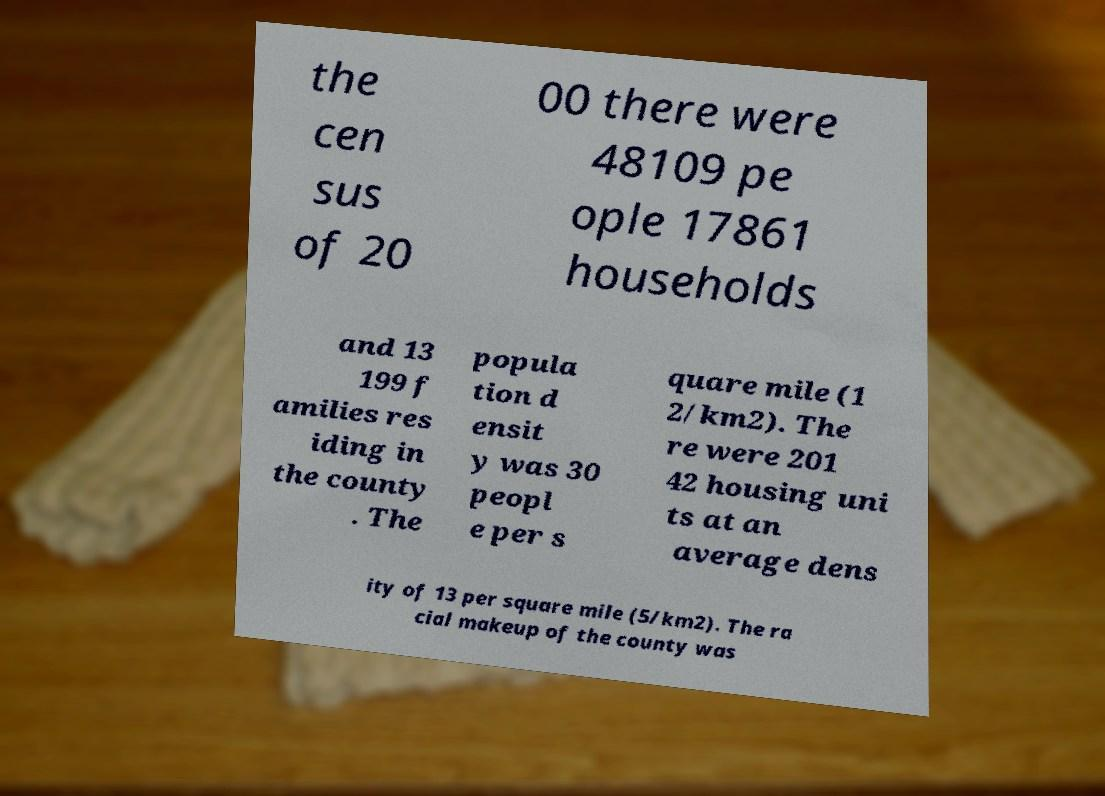There's text embedded in this image that I need extracted. Can you transcribe it verbatim? the cen sus of 20 00 there were 48109 pe ople 17861 households and 13 199 f amilies res iding in the county . The popula tion d ensit y was 30 peopl e per s quare mile (1 2/km2). The re were 201 42 housing uni ts at an average dens ity of 13 per square mile (5/km2). The ra cial makeup of the county was 